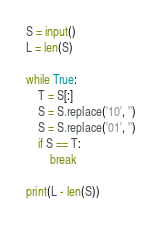Convert code to text. <code><loc_0><loc_0><loc_500><loc_500><_Python_>S = input()
L = len(S)

while True:
    T = S[:]
    S = S.replace('10', '')
    S = S.replace('01', '')
    if S == T:
        break

print(L - len(S))
</code> 